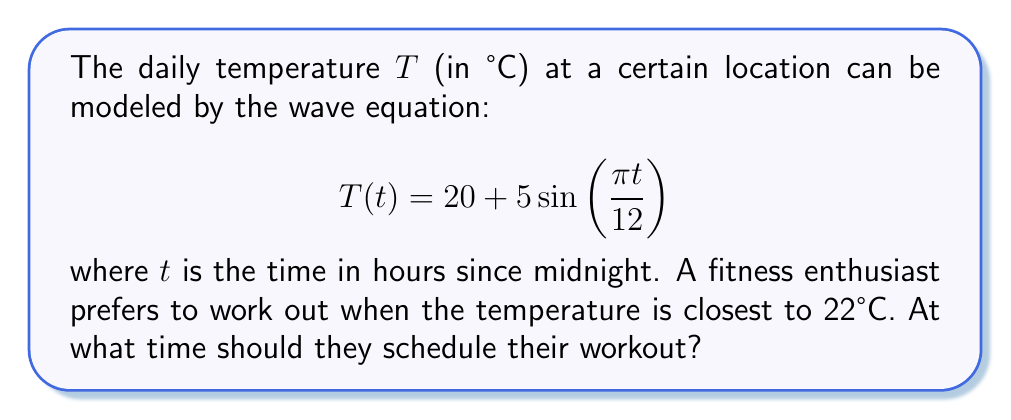Provide a solution to this math problem. 1) To find the optimal time, we need to determine when T(t) = 22°C. Let's set up the equation:

   $$22 = 20 + 5\sin\left(\frac{\pi t}{12}\right)$$

2) Subtract 20 from both sides:

   $$2 = 5\sin\left(\frac{\pi t}{12}\right)$$

3) Divide both sides by 5:

   $$\frac{2}{5} = \sin\left(\frac{\pi t}{12}\right)$$

4) Take the inverse sine (arcsin) of both sides:

   $$\arcsin\left(\frac{2}{5}\right) = \frac{\pi t}{12}$$

5) Multiply both sides by 12/π:

   $$\frac{12}{\pi}\arcsin\left(\frac{2}{5}\right) = t$$

6) Calculate the value:

   $$t \approx 2.43 \text{ hours}$$

7) Convert to hours and minutes:
   2.43 hours = 2 hours and 0.43 * 60 ≈ 26 minutes

8) Since time starts at midnight, 2:26 AM is the first solution.

9) Due to the periodic nature of sine, there's a second solution 12 hours later at 2:26 PM.

10) The 2:26 PM workout time is more practical for most people's schedules.
Answer: 2:26 PM 